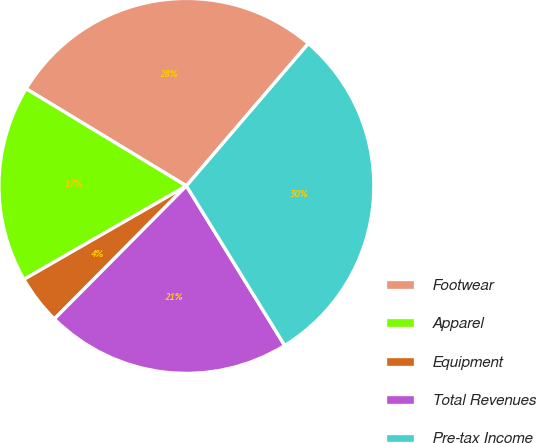Convert chart. <chart><loc_0><loc_0><loc_500><loc_500><pie_chart><fcel>Footwear<fcel>Apparel<fcel>Equipment<fcel>Total Revenues<fcel>Pre-tax Income<nl><fcel>27.6%<fcel>16.99%<fcel>4.25%<fcel>21.23%<fcel>29.94%<nl></chart> 